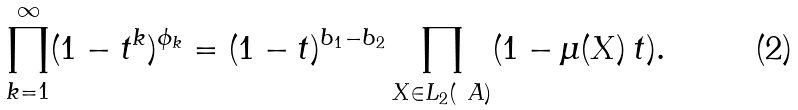<formula> <loc_0><loc_0><loc_500><loc_500>\prod _ { k = 1 } ^ { \infty } ( 1 - t ^ { k } ) ^ { \phi _ { k } } = ( 1 - t ) ^ { b _ { 1 } - b _ { 2 } } \prod _ { X \in L _ { 2 } ( \ A ) } ( 1 - \mu ( X ) \, t ) .</formula> 